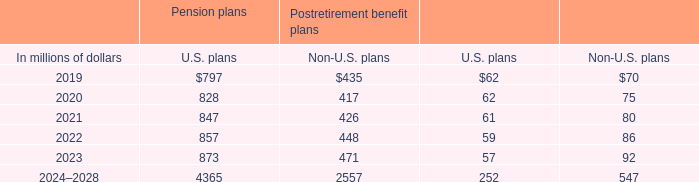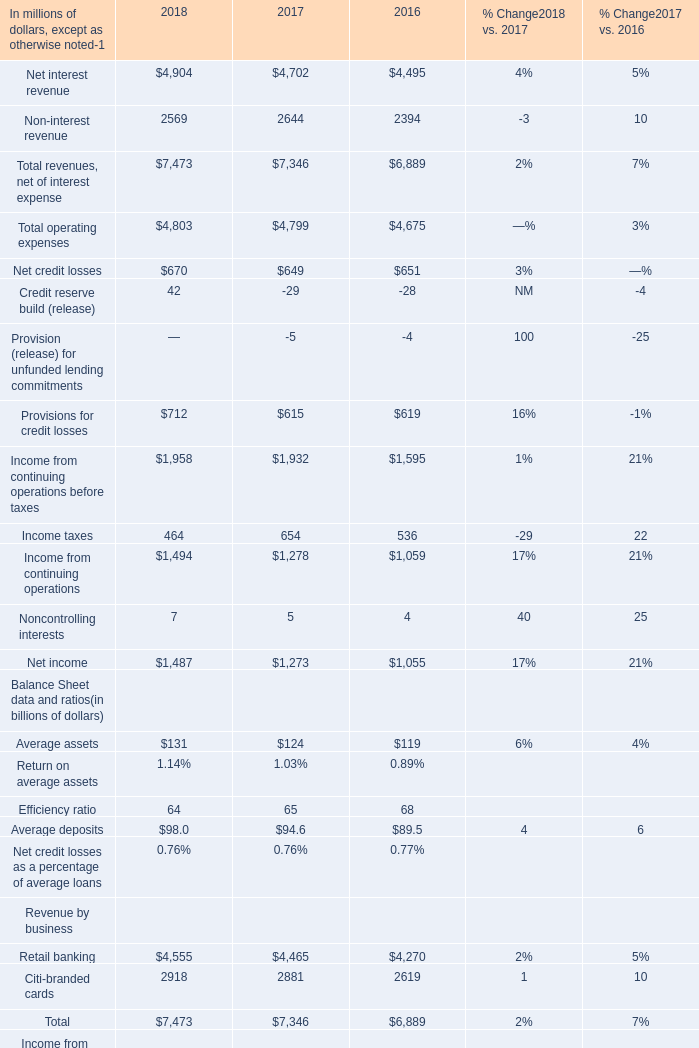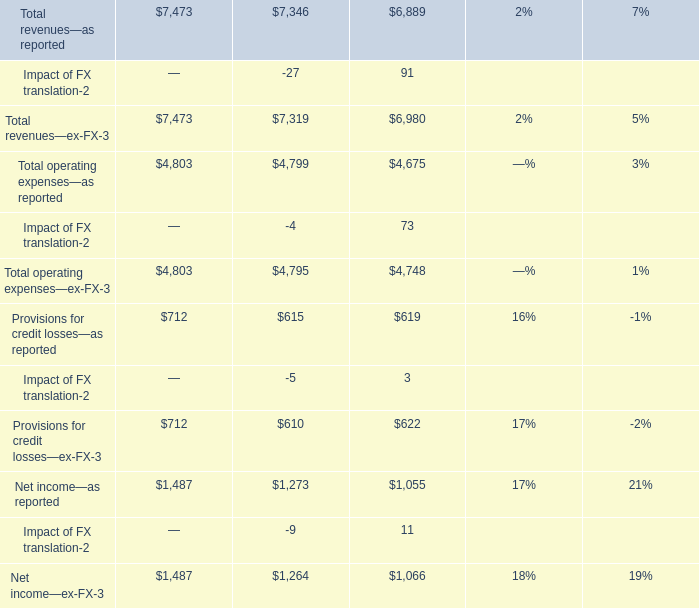What do all Credit reserve build sum up, excluding those negative ones in all year ? 
Answer: 42. 